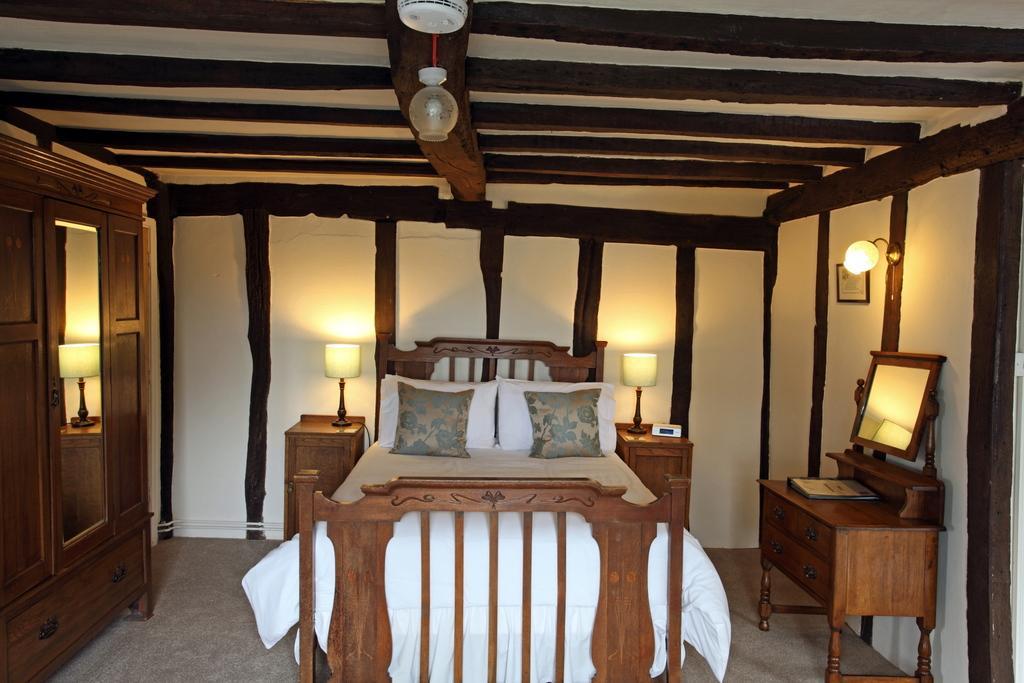Describe this image in one or two sentences. In this image, we can see a room with a bed and some pillows. We can also see some lamps. On the left, we can see a wardrobe and on the right, we can see a table with a mirror on it. We can also see the wall with a lamp and frame on it. We can also see the roof. 